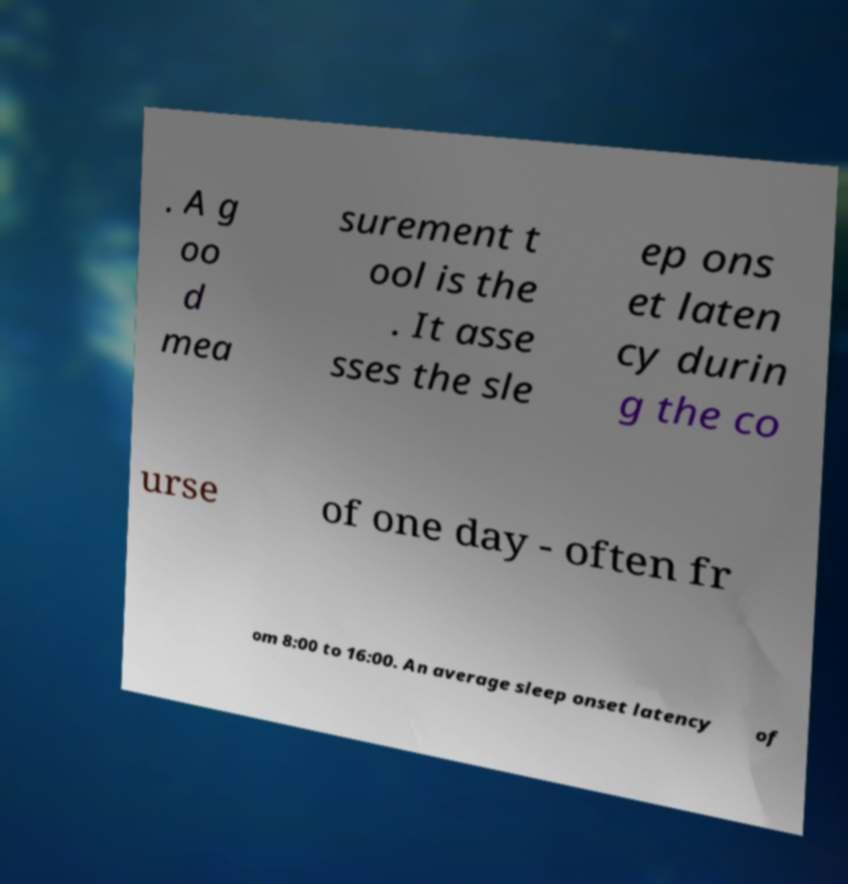Please identify and transcribe the text found in this image. . A g oo d mea surement t ool is the . It asse sses the sle ep ons et laten cy durin g the co urse of one day - often fr om 8:00 to 16:00. An average sleep onset latency of 